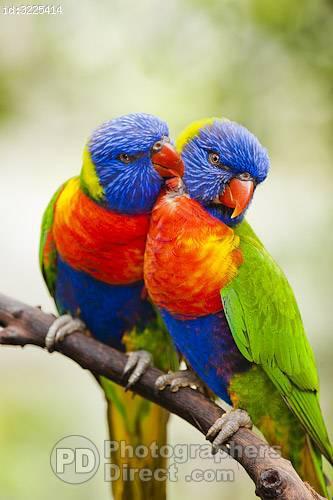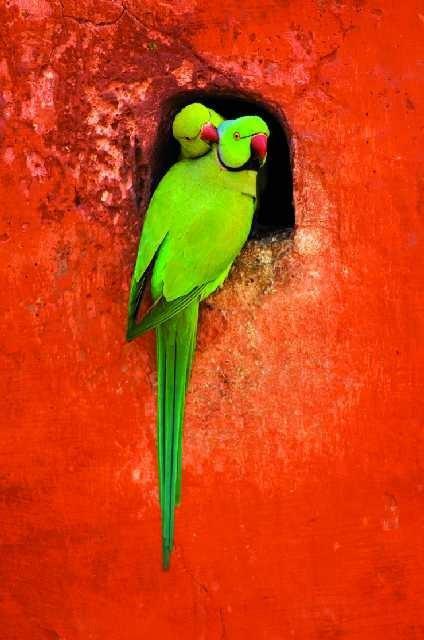The first image is the image on the left, the second image is the image on the right. Considering the images on both sides, is "In at least one of the pictures, there are two birds that are both the same color." valid? Answer yes or no. Yes. 